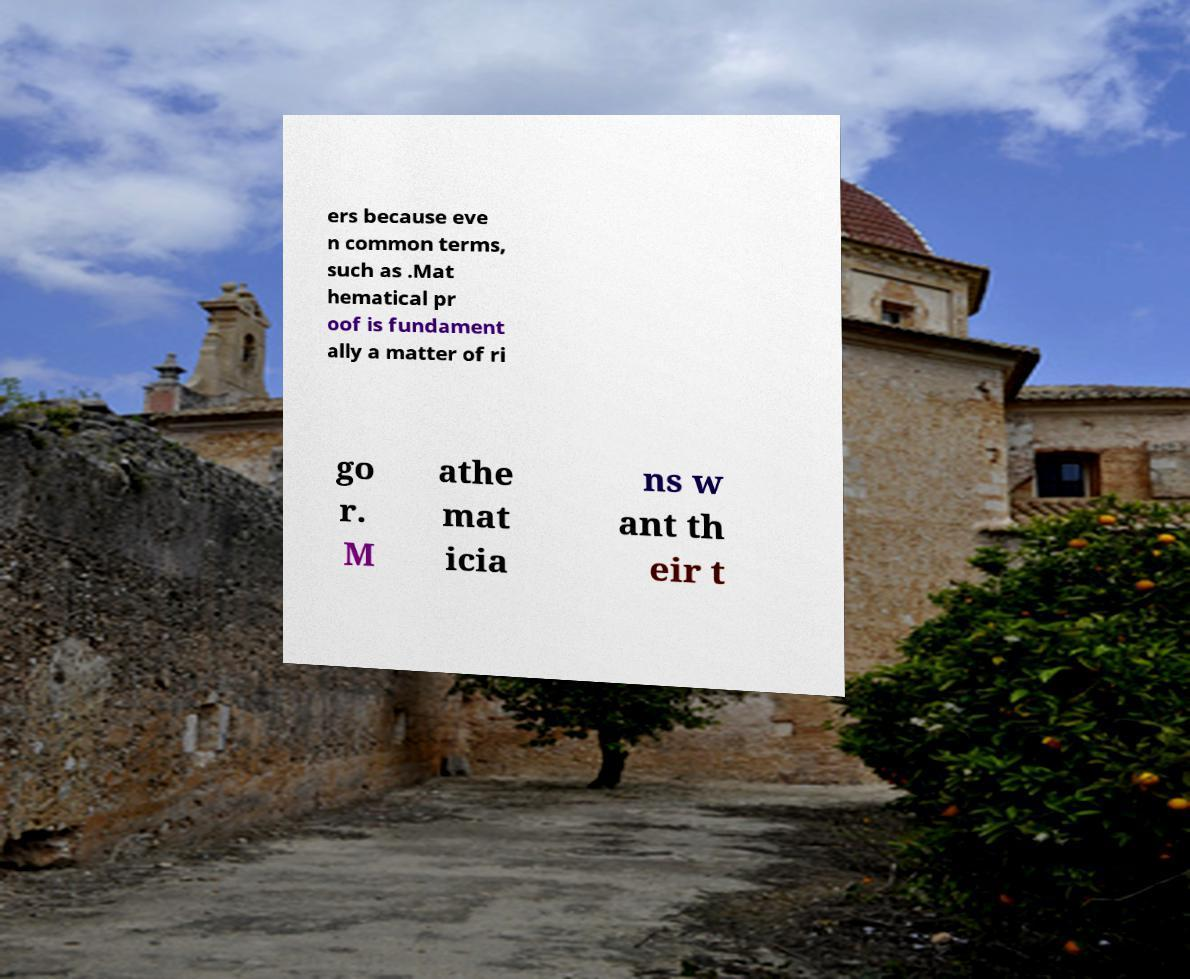What messages or text are displayed in this image? I need them in a readable, typed format. ers because eve n common terms, such as .Mat hematical pr oof is fundament ally a matter of ri go r. M athe mat icia ns w ant th eir t 